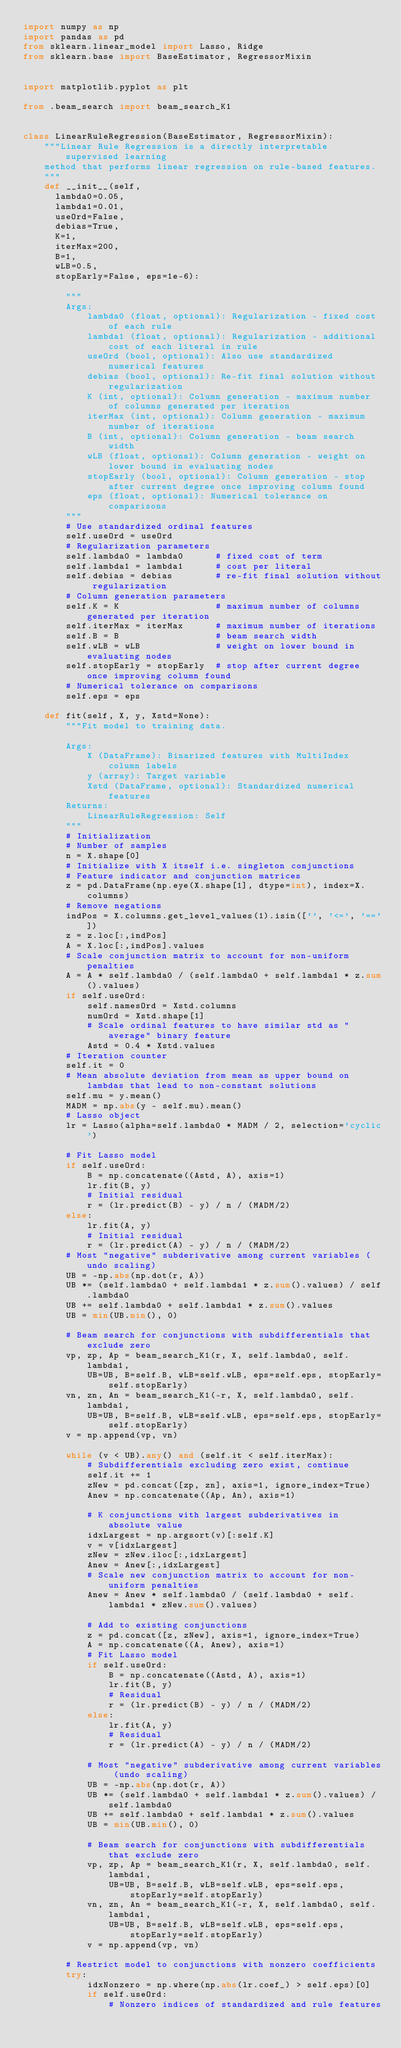Convert code to text. <code><loc_0><loc_0><loc_500><loc_500><_Python_>import numpy as np
import pandas as pd
from sklearn.linear_model import Lasso, Ridge
from sklearn.base import BaseEstimator, RegressorMixin


import matplotlib.pyplot as plt

from .beam_search import beam_search_K1


class LinearRuleRegression(BaseEstimator, RegressorMixin):
    """Linear Rule Regression is a directly interpretable supervised learning
    method that performs linear regression on rule-based features.
    """
    def __init__(self,
      lambda0=0.05,
      lambda1=0.01,
      useOrd=False,
      debias=True,
      K=1,
      iterMax=200,
      B=1,
      wLB=0.5,
      stopEarly=False, eps=1e-6):

        """
        Args:
            lambda0 (float, optional): Regularization - fixed cost of each rule
            lambda1 (float, optional): Regularization - additional cost of each literal in rule
            useOrd (bool, optional): Also use standardized numerical features
            debias (bool, optional): Re-fit final solution without regularization
            K (int, optional): Column generation - maximum number of columns generated per iteration
            iterMax (int, optional): Column generation - maximum number of iterations
            B (int, optional): Column generation - beam search width
            wLB (float, optional): Column generation - weight on lower bound in evaluating nodes
            stopEarly (bool, optional): Column generation - stop after current degree once improving column found
            eps (float, optional): Numerical tolerance on comparisons
        """
        # Use standardized ordinal features
        self.useOrd = useOrd
        # Regularization parameters
        self.lambda0 = lambda0      # fixed cost of term
        self.lambda1 = lambda1      # cost per literal
        self.debias = debias        # re-fit final solution without regularization
        # Column generation parameters
        self.K = K                  # maximum number of columns generated per iteration
        self.iterMax = iterMax      # maximum number of iterations
        self.B = B                  # beam search width
        self.wLB = wLB              # weight on lower bound in evaluating nodes
        self.stopEarly = stopEarly  # stop after current degree once improving column found
        # Numerical tolerance on comparisons
        self.eps = eps

    def fit(self, X, y, Xstd=None):
        """Fit model to training data.

        Args:
            X (DataFrame): Binarized features with MultiIndex column labels
            y (array): Target variable
            Xstd (DataFrame, optional): Standardized numerical features
        Returns:
            LinearRuleRegression: Self
        """
        # Initialization
        # Number of samples
        n = X.shape[0]
        # Initialize with X itself i.e. singleton conjunctions
        # Feature indicator and conjunction matrices
        z = pd.DataFrame(np.eye(X.shape[1], dtype=int), index=X.columns)
        # Remove negations
        indPos = X.columns.get_level_values(1).isin(['', '<=', '=='])
        z = z.loc[:,indPos]
        A = X.loc[:,indPos].values
        # Scale conjunction matrix to account for non-uniform penalties
        A = A * self.lambda0 / (self.lambda0 + self.lambda1 * z.sum().values)
        if self.useOrd:
            self.namesOrd = Xstd.columns
            numOrd = Xstd.shape[1]
            # Scale ordinal features to have similar std as "average" binary feature
            Astd = 0.4 * Xstd.values
        # Iteration counter
        self.it = 0
        # Mean absolute deviation from mean as upper bound on lambdas that lead to non-constant solutions
        self.mu = y.mean()
        MADM = np.abs(y - self.mu).mean()
        # Lasso object
        lr = Lasso(alpha=self.lambda0 * MADM / 2, selection='cyclic')

        # Fit Lasso model
        if self.useOrd:
            B = np.concatenate((Astd, A), axis=1)
            lr.fit(B, y)
            # Initial residual
            r = (lr.predict(B) - y) / n / (MADM/2)
        else:
            lr.fit(A, y)
            # Initial residual
            r = (lr.predict(A) - y) / n / (MADM/2)
        # Most "negative" subderivative among current variables (undo scaling)
        UB = -np.abs(np.dot(r, A))
        UB *= (self.lambda0 + self.lambda1 * z.sum().values) / self.lambda0
        UB += self.lambda0 + self.lambda1 * z.sum().values
        UB = min(UB.min(), 0)

        # Beam search for conjunctions with subdifferentials that exclude zero
        vp, zp, Ap = beam_search_K1(r, X, self.lambda0, self.lambda1,
            UB=UB, B=self.B, wLB=self.wLB, eps=self.eps, stopEarly=self.stopEarly)
        vn, zn, An = beam_search_K1(-r, X, self.lambda0, self.lambda1,
            UB=UB, B=self.B, wLB=self.wLB, eps=self.eps, stopEarly=self.stopEarly)
        v = np.append(vp, vn)

        while (v < UB).any() and (self.it < self.iterMax):
            # Subdifferentials excluding zero exist, continue
            self.it += 1
            zNew = pd.concat([zp, zn], axis=1, ignore_index=True)
            Anew = np.concatenate((Ap, An), axis=1)

            # K conjunctions with largest subderivatives in absolute value
            idxLargest = np.argsort(v)[:self.K]
            v = v[idxLargest]
            zNew = zNew.iloc[:,idxLargest]
            Anew = Anew[:,idxLargest]
            # Scale new conjunction matrix to account for non-uniform penalties
            Anew = Anew * self.lambda0 / (self.lambda0 + self.lambda1 * zNew.sum().values)

            # Add to existing conjunctions
            z = pd.concat([z, zNew], axis=1, ignore_index=True)
            A = np.concatenate((A, Anew), axis=1)
            # Fit Lasso model
            if self.useOrd:
                B = np.concatenate((Astd, A), axis=1)
                lr.fit(B, y)
                # Residual
                r = (lr.predict(B) - y) / n / (MADM/2)
            else:
                lr.fit(A, y)
                # Residual
                r = (lr.predict(A) - y) / n / (MADM/2)

            # Most "negative" subderivative among current variables (undo scaling)
            UB = -np.abs(np.dot(r, A))
            UB *= (self.lambda0 + self.lambda1 * z.sum().values) / self.lambda0
            UB += self.lambda0 + self.lambda1 * z.sum().values
            UB = min(UB.min(), 0)

            # Beam search for conjunctions with subdifferentials that exclude zero
            vp, zp, Ap = beam_search_K1(r, X, self.lambda0, self.lambda1,
                UB=UB, B=self.B, wLB=self.wLB, eps=self.eps, stopEarly=self.stopEarly)
            vn, zn, An = beam_search_K1(-r, X, self.lambda0, self.lambda1,
                UB=UB, B=self.B, wLB=self.wLB, eps=self.eps, stopEarly=self.stopEarly)
            v = np.append(vp, vn)

        # Restrict model to conjunctions with nonzero coefficients
        try:
            idxNonzero = np.where(np.abs(lr.coef_) > self.eps)[0]
            if self.useOrd:
                # Nonzero indices of standardized and rule features</code> 